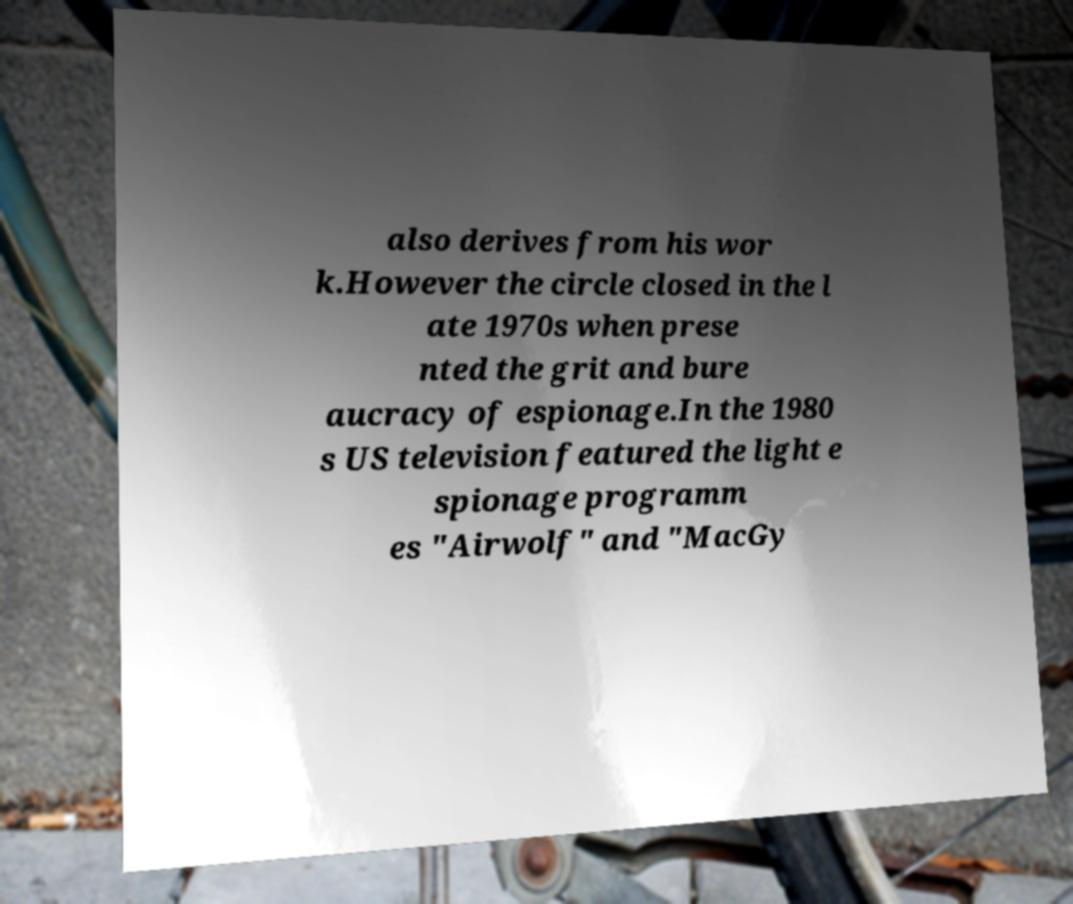Please identify and transcribe the text found in this image. also derives from his wor k.However the circle closed in the l ate 1970s when prese nted the grit and bure aucracy of espionage.In the 1980 s US television featured the light e spionage programm es "Airwolf" and "MacGy 